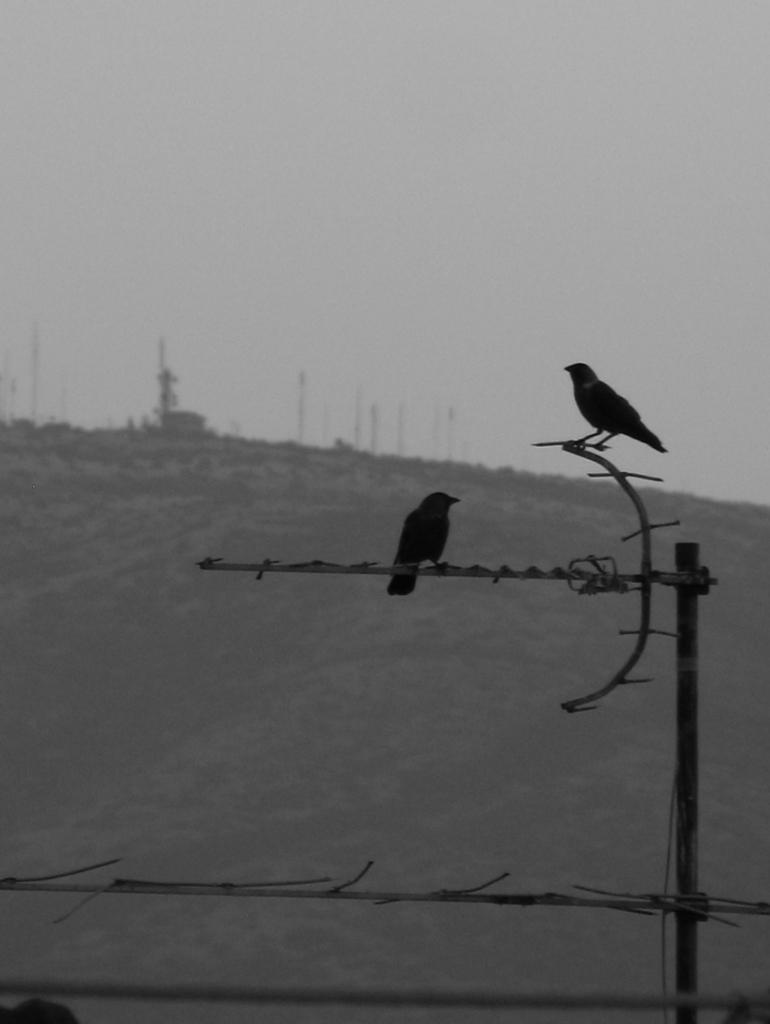Please provide a concise description of this image. In this picture there are two crows were standing on the tower. In the background we can see the mountain and plants. At the top of the mountain i can see many poles. At the top i can see the sky and clouds. 